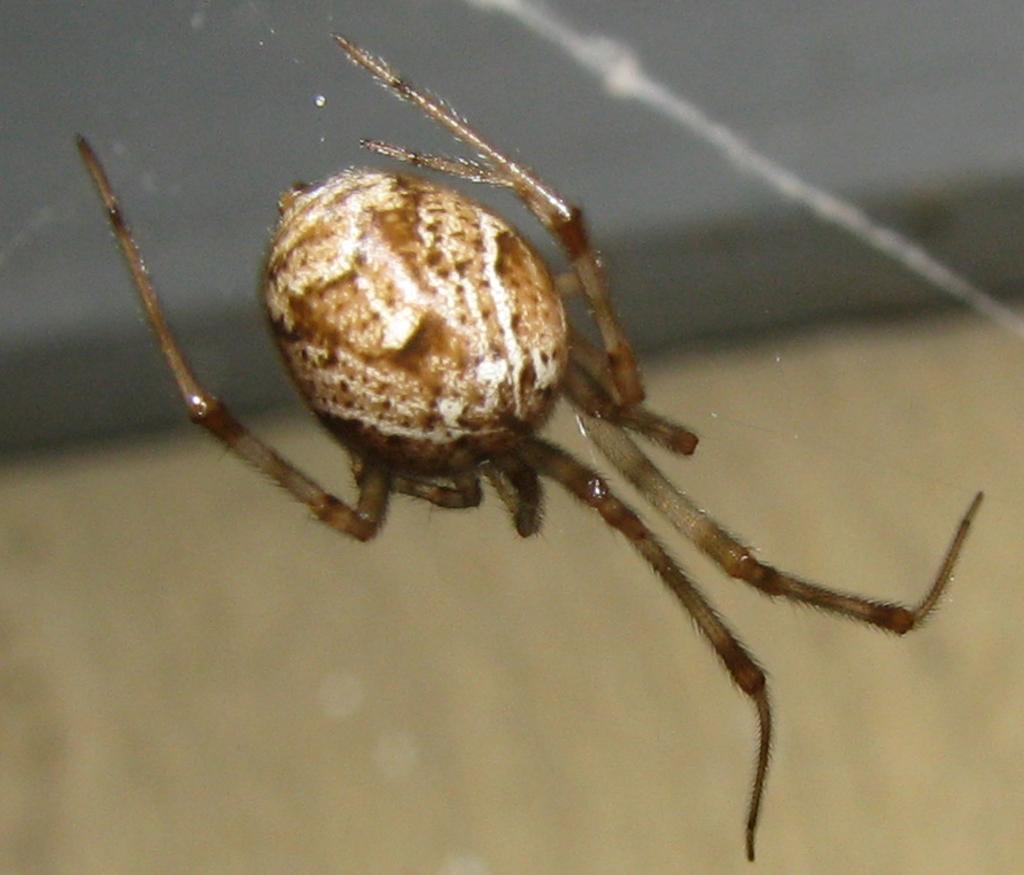Describe this image in one or two sentences. In this picture I can observe an insect in the middle of the picture. It is looking like spider. The background is completely blurred. 